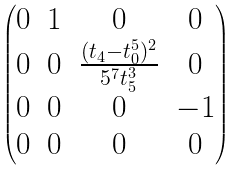<formula> <loc_0><loc_0><loc_500><loc_500>\begin{pmatrix} 0 & 1 & 0 & 0 \\ 0 & 0 & \frac { ( t _ { 4 } - t _ { 0 } ^ { 5 } ) ^ { 2 } } { 5 ^ { 7 } t _ { 5 } ^ { 3 } } & 0 \\ 0 & 0 & 0 & - 1 \\ 0 & 0 & 0 & 0 \end{pmatrix}</formula> 